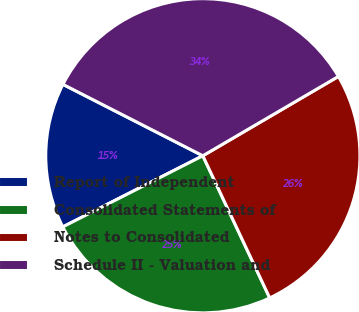<chart> <loc_0><loc_0><loc_500><loc_500><pie_chart><fcel>Report of Independent<fcel>Consolidated Statements of<fcel>Notes to Consolidated<fcel>Schedule II - Valuation and<nl><fcel>14.99%<fcel>24.52%<fcel>26.43%<fcel>34.06%<nl></chart> 